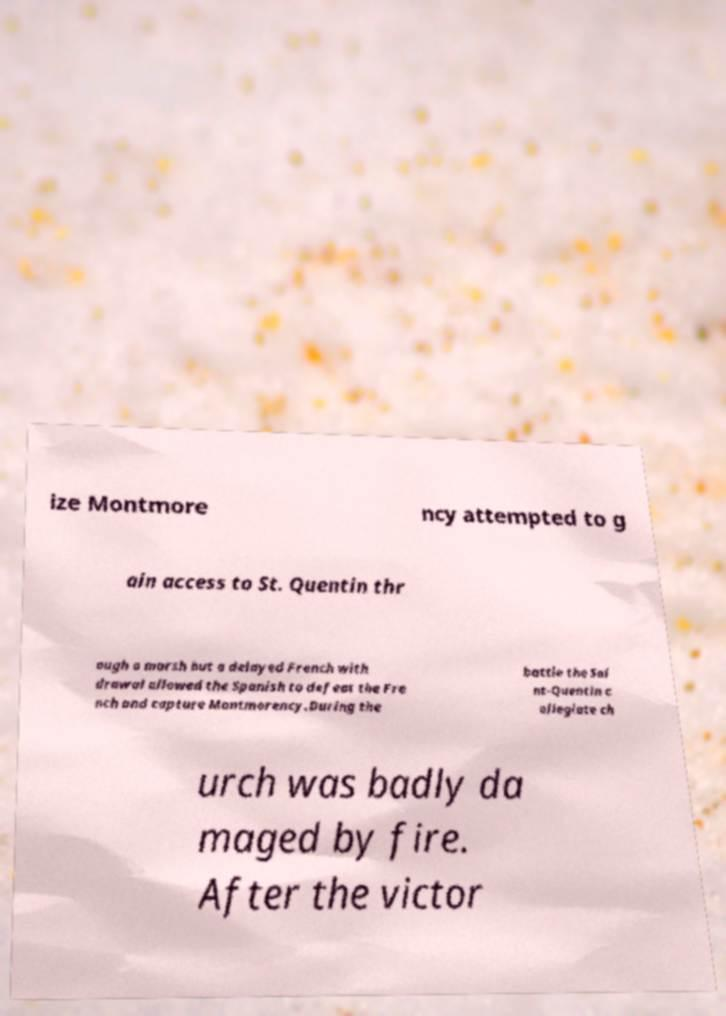Could you assist in decoding the text presented in this image and type it out clearly? ize Montmore ncy attempted to g ain access to St. Quentin thr ough a marsh but a delayed French with drawal allowed the Spanish to defeat the Fre nch and capture Montmorency.During the battle the Sai nt-Quentin c ollegiate ch urch was badly da maged by fire. After the victor 